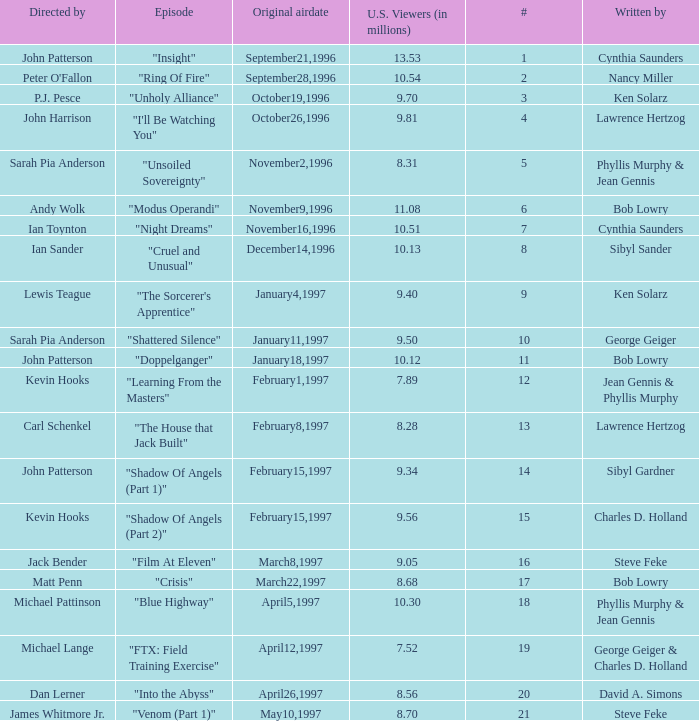Who wrote the episode with 9.81 million US viewers? Lawrence Hertzog. Give me the full table as a dictionary. {'header': ['Directed by', 'Episode', 'Original airdate', 'U.S. Viewers (in millions)', '#', 'Written by'], 'rows': [['John Patterson', '"Insight"', 'September21,1996', '13.53', '1', 'Cynthia Saunders'], ["Peter O'Fallon", '"Ring Of Fire"', 'September28,1996', '10.54', '2', 'Nancy Miller'], ['P.J. Pesce', '"Unholy Alliance"', 'October19,1996', '9.70', '3', 'Ken Solarz'], ['John Harrison', '"I\'ll Be Watching You"', 'October26,1996', '9.81', '4', 'Lawrence Hertzog'], ['Sarah Pia Anderson', '"Unsoiled Sovereignty"', 'November2,1996', '8.31', '5', 'Phyllis Murphy & Jean Gennis'], ['Andy Wolk', '"Modus Operandi"', 'November9,1996', '11.08', '6', 'Bob Lowry'], ['Ian Toynton', '"Night Dreams"', 'November16,1996', '10.51', '7', 'Cynthia Saunders'], ['Ian Sander', '"Cruel and Unusual"', 'December14,1996', '10.13', '8', 'Sibyl Sander'], ['Lewis Teague', '"The Sorcerer\'s Apprentice"', 'January4,1997', '9.40', '9', 'Ken Solarz'], ['Sarah Pia Anderson', '"Shattered Silence"', 'January11,1997', '9.50', '10', 'George Geiger'], ['John Patterson', '"Doppelganger"', 'January18,1997', '10.12', '11', 'Bob Lowry'], ['Kevin Hooks', '"Learning From the Masters"', 'February1,1997', '7.89', '12', 'Jean Gennis & Phyllis Murphy'], ['Carl Schenkel', '"The House that Jack Built"', 'February8,1997', '8.28', '13', 'Lawrence Hertzog'], ['John Patterson', '"Shadow Of Angels (Part 1)"', 'February15,1997', '9.34', '14', 'Sibyl Gardner'], ['Kevin Hooks', '"Shadow Of Angels (Part 2)"', 'February15,1997', '9.56', '15', 'Charles D. Holland'], ['Jack Bender', '"Film At Eleven"', 'March8,1997', '9.05', '16', 'Steve Feke'], ['Matt Penn', '"Crisis"', 'March22,1997', '8.68', '17', 'Bob Lowry'], ['Michael Pattinson', '"Blue Highway"', 'April5,1997', '10.30', '18', 'Phyllis Murphy & Jean Gennis'], ['Michael Lange', '"FTX: Field Training Exercise"', 'April12,1997', '7.52', '19', 'George Geiger & Charles D. Holland'], ['Dan Lerner', '"Into the Abyss"', 'April26,1997', '8.56', '20', 'David A. Simons'], ['James Whitmore Jr.', '"Venom (Part 1)"', 'May10,1997', '8.70', '21', 'Steve Feke']]} 